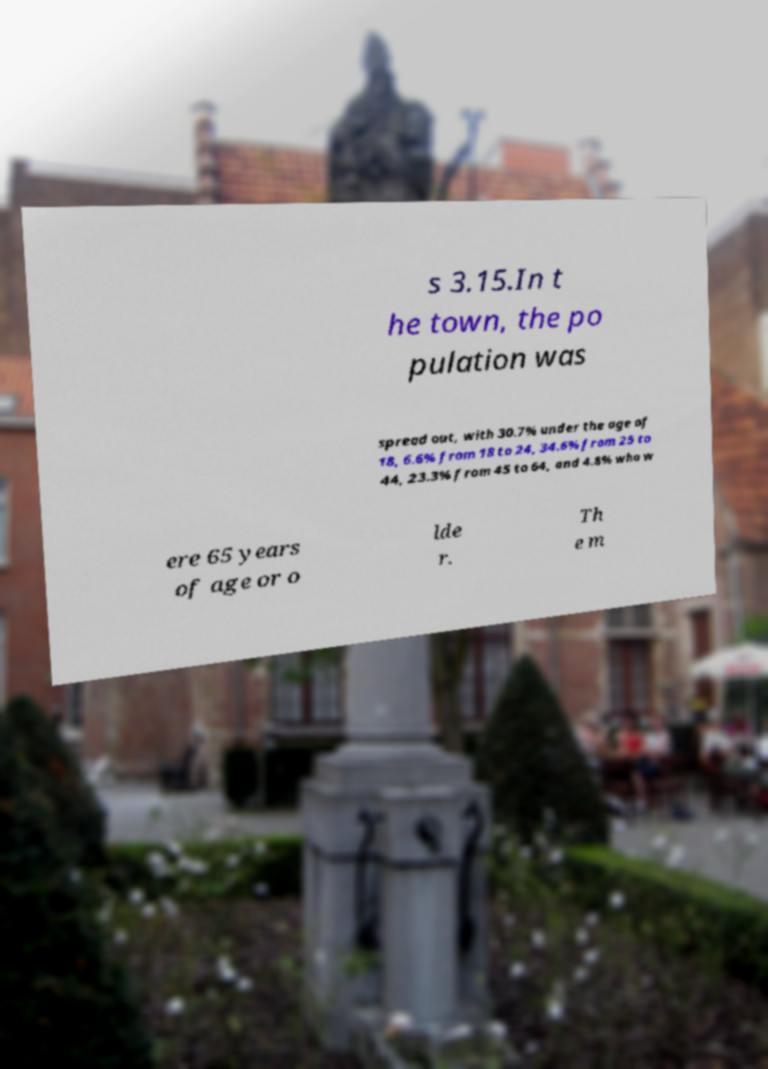What messages or text are displayed in this image? I need them in a readable, typed format. s 3.15.In t he town, the po pulation was spread out, with 30.7% under the age of 18, 6.6% from 18 to 24, 34.6% from 25 to 44, 23.3% from 45 to 64, and 4.8% who w ere 65 years of age or o lde r. Th e m 